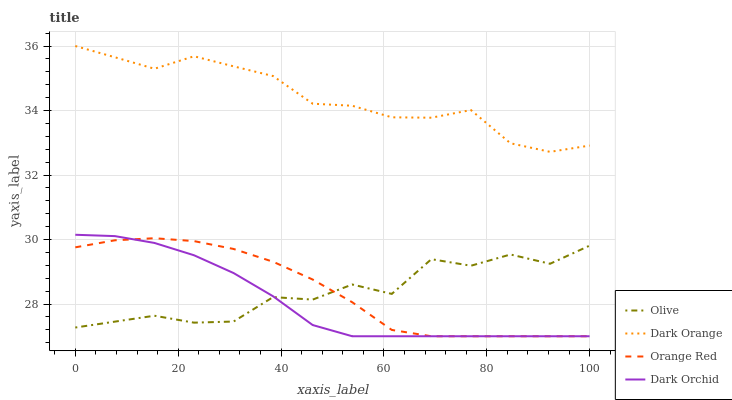Does Dark Orchid have the minimum area under the curve?
Answer yes or no. Yes. Does Dark Orange have the maximum area under the curve?
Answer yes or no. Yes. Does Orange Red have the minimum area under the curve?
Answer yes or no. No. Does Orange Red have the maximum area under the curve?
Answer yes or no. No. Is Dark Orchid the smoothest?
Answer yes or no. Yes. Is Olive the roughest?
Answer yes or no. Yes. Is Dark Orange the smoothest?
Answer yes or no. No. Is Dark Orange the roughest?
Answer yes or no. No. Does Orange Red have the lowest value?
Answer yes or no. Yes. Does Dark Orange have the lowest value?
Answer yes or no. No. Does Dark Orange have the highest value?
Answer yes or no. Yes. Does Orange Red have the highest value?
Answer yes or no. No. Is Orange Red less than Dark Orange?
Answer yes or no. Yes. Is Dark Orange greater than Dark Orchid?
Answer yes or no. Yes. Does Dark Orchid intersect Olive?
Answer yes or no. Yes. Is Dark Orchid less than Olive?
Answer yes or no. No. Is Dark Orchid greater than Olive?
Answer yes or no. No. Does Orange Red intersect Dark Orange?
Answer yes or no. No. 